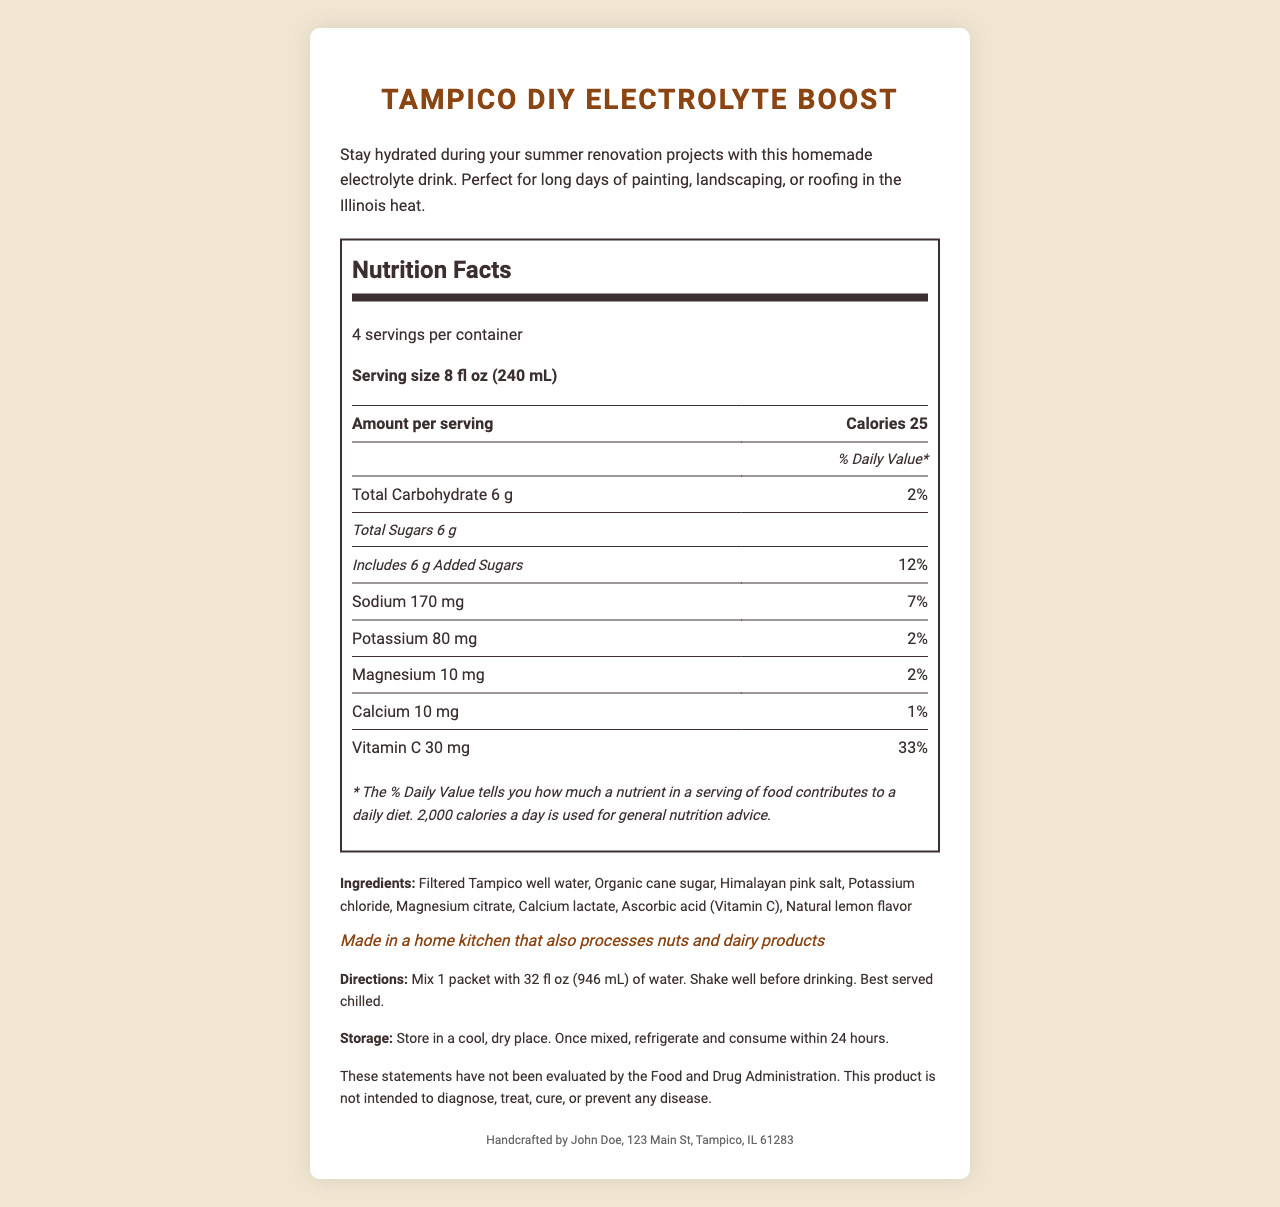what is the serving size? The document states the serving size is 8 fl oz (240 mL).
Answer: 8 fl oz (240 mL) how many servings per container? The document mentions there are 4 servings per container.
Answer: 4 how many calories are in each serving? The document specifies that each serving contains 25 calories.
Answer: 25 what is the total amount of sugars per serving? The document indicates that the total amount of sugars per serving is 6 g.
Answer: 6 g what is the percentage of the daily value for sodium? According to the document, the percent daily value for sodium is 7%.
Answer: 7% what is the main source of hydration in this drink? A. Potassium chloride B. Filtered Tampico well water C. Magnesium citrate The ingredients list shows that the primary source of hydration is filtered Tampico well water.
Answer: B which of these ingredients provides vitamin C? A. Calcium lactate B. Ascorbic acid C. Magnesium citrate The document lists "Ascorbic acid (Vitamin C)" as an ingredient, indicating it provides Vitamin C.
Answer: B is there any allergen information provided? The document includes an allergen information section stating it's made in a home kitchen that also processes nuts and dairy products.
Answer: Yes is this product intended to diagnose, treat, cure, or prevent any disease? The disclaimer clearly states that the product is not intended to diagnose, treat, cure, or prevent any disease.
Answer: No how should the product be stored after mixing? The document instructs to store the product in a refrigerator and consume it within 24 hours once mixed.
Answer: Refrigerate and consume within 24 hours describe the main purpose of this document. The document summarizes all essential details about the product, including its nutritional content, preparation and storage methods, allergen information, and manufacturer details, all geared towards aiding hydration in DIY home improvement scenarios.
Answer: The document provides detailed nutrition facts, ingredients, directions, storage instructions, and other important information about the homemade electrolyte drink "Tampico DIY Electrolyte Boost," which is designed to help stay hydrated during summer renovation projects. who is the manufacturer of the product? The document lists John Doe, 123 Main St, Tampico, IL 61283 as the manufacturer.
Answer: John Doe how much potassium is in one serving? The document states that one serving contains 80 mg of potassium.
Answer: 80 mg what percentage of daily value for vitamin C does one serving provide? The document states that each serving provides 33% of the daily value for vitamin C.
Answer: 33% what drink should you mix with the packet? A. Tap water B. Distilled water C. 32 fl oz (946 mL) of water The directions specify to mix one packet with 32 fl oz (946 mL) of water.
Answer: C what is the percentage daily value of calcium per serving? The document states that the percent daily value of calcium per serving is 1%.
Answer: 1% does the document state the concentration of the drink in grams per liter? The document does not provide information about the concentration of the drink in terms of grams per liter.
Answer: Not enough information 